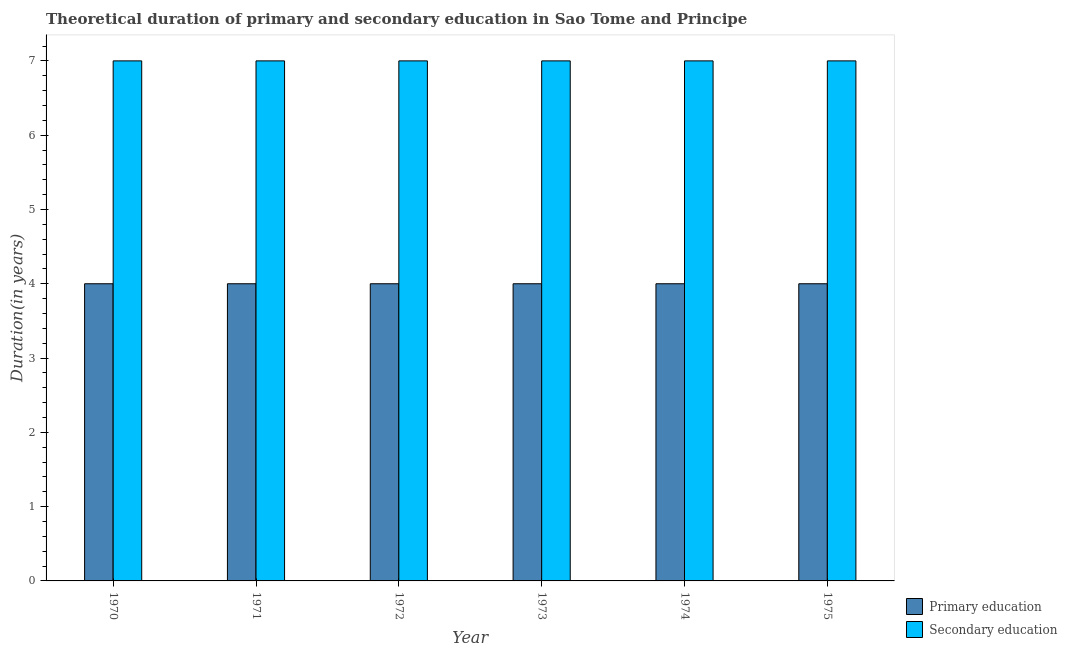How many different coloured bars are there?
Your answer should be very brief. 2. How many groups of bars are there?
Provide a short and direct response. 6. Are the number of bars per tick equal to the number of legend labels?
Your response must be concise. Yes. Are the number of bars on each tick of the X-axis equal?
Offer a very short reply. Yes. How many bars are there on the 2nd tick from the left?
Keep it short and to the point. 2. What is the label of the 4th group of bars from the left?
Provide a short and direct response. 1973. What is the duration of secondary education in 1975?
Ensure brevity in your answer.  7. Across all years, what is the maximum duration of secondary education?
Offer a very short reply. 7. Across all years, what is the minimum duration of secondary education?
Your answer should be very brief. 7. In which year was the duration of secondary education maximum?
Keep it short and to the point. 1970. What is the total duration of primary education in the graph?
Keep it short and to the point. 24. What is the difference between the duration of primary education in 1970 and that in 1971?
Offer a very short reply. 0. In how many years, is the duration of primary education greater than 2.4 years?
Your answer should be compact. 6. What is the difference between the highest and the second highest duration of secondary education?
Keep it short and to the point. 0. In how many years, is the duration of secondary education greater than the average duration of secondary education taken over all years?
Offer a very short reply. 0. Is the sum of the duration of secondary education in 1970 and 1971 greater than the maximum duration of primary education across all years?
Make the answer very short. Yes. How many bars are there?
Your answer should be very brief. 12. Are all the bars in the graph horizontal?
Keep it short and to the point. No. How many years are there in the graph?
Provide a succinct answer. 6. What is the difference between two consecutive major ticks on the Y-axis?
Your response must be concise. 1. Are the values on the major ticks of Y-axis written in scientific E-notation?
Keep it short and to the point. No. Does the graph contain grids?
Offer a terse response. No. How many legend labels are there?
Your answer should be compact. 2. How are the legend labels stacked?
Your response must be concise. Vertical. What is the title of the graph?
Ensure brevity in your answer.  Theoretical duration of primary and secondary education in Sao Tome and Principe. What is the label or title of the Y-axis?
Keep it short and to the point. Duration(in years). What is the Duration(in years) in Primary education in 1970?
Keep it short and to the point. 4. What is the Duration(in years) of Secondary education in 1972?
Your answer should be very brief. 7. What is the Duration(in years) of Secondary education in 1973?
Make the answer very short. 7. What is the Duration(in years) in Primary education in 1974?
Provide a succinct answer. 4. What is the Duration(in years) in Secondary education in 1974?
Offer a terse response. 7. What is the Duration(in years) in Primary education in 1975?
Provide a succinct answer. 4. Across all years, what is the maximum Duration(in years) of Secondary education?
Make the answer very short. 7. Across all years, what is the minimum Duration(in years) in Secondary education?
Keep it short and to the point. 7. What is the total Duration(in years) of Primary education in the graph?
Provide a succinct answer. 24. What is the difference between the Duration(in years) in Primary education in 1970 and that in 1971?
Your answer should be very brief. 0. What is the difference between the Duration(in years) in Secondary education in 1970 and that in 1971?
Your answer should be very brief. 0. What is the difference between the Duration(in years) of Primary education in 1970 and that in 1972?
Offer a terse response. 0. What is the difference between the Duration(in years) of Secondary education in 1970 and that in 1972?
Offer a terse response. 0. What is the difference between the Duration(in years) of Primary education in 1970 and that in 1973?
Provide a short and direct response. 0. What is the difference between the Duration(in years) of Secondary education in 1970 and that in 1974?
Your answer should be compact. 0. What is the difference between the Duration(in years) in Secondary education in 1970 and that in 1975?
Offer a terse response. 0. What is the difference between the Duration(in years) in Primary education in 1971 and that in 1972?
Provide a short and direct response. 0. What is the difference between the Duration(in years) in Secondary education in 1971 and that in 1973?
Offer a terse response. 0. What is the difference between the Duration(in years) in Primary education in 1971 and that in 1974?
Your answer should be compact. 0. What is the difference between the Duration(in years) of Secondary education in 1971 and that in 1975?
Offer a terse response. 0. What is the difference between the Duration(in years) in Primary education in 1972 and that in 1973?
Provide a succinct answer. 0. What is the difference between the Duration(in years) of Secondary education in 1972 and that in 1973?
Your answer should be very brief. 0. What is the difference between the Duration(in years) of Primary education in 1972 and that in 1974?
Offer a terse response. 0. What is the difference between the Duration(in years) of Secondary education in 1972 and that in 1974?
Your answer should be compact. 0. What is the difference between the Duration(in years) of Primary education in 1972 and that in 1975?
Provide a short and direct response. 0. What is the difference between the Duration(in years) in Primary education in 1973 and that in 1974?
Provide a succinct answer. 0. What is the difference between the Duration(in years) of Primary education in 1973 and that in 1975?
Offer a very short reply. 0. What is the difference between the Duration(in years) of Primary education in 1974 and that in 1975?
Offer a very short reply. 0. What is the difference between the Duration(in years) in Primary education in 1970 and the Duration(in years) in Secondary education in 1971?
Provide a short and direct response. -3. What is the difference between the Duration(in years) of Primary education in 1970 and the Duration(in years) of Secondary education in 1972?
Offer a terse response. -3. What is the difference between the Duration(in years) of Primary education in 1971 and the Duration(in years) of Secondary education in 1972?
Give a very brief answer. -3. What is the difference between the Duration(in years) of Primary education in 1971 and the Duration(in years) of Secondary education in 1973?
Your answer should be compact. -3. What is the difference between the Duration(in years) in Primary education in 1972 and the Duration(in years) in Secondary education in 1974?
Make the answer very short. -3. What is the difference between the Duration(in years) in Primary education in 1972 and the Duration(in years) in Secondary education in 1975?
Offer a very short reply. -3. What is the difference between the Duration(in years) of Primary education in 1973 and the Duration(in years) of Secondary education in 1974?
Provide a succinct answer. -3. What is the difference between the Duration(in years) in Primary education in 1973 and the Duration(in years) in Secondary education in 1975?
Keep it short and to the point. -3. What is the difference between the Duration(in years) of Primary education in 1974 and the Duration(in years) of Secondary education in 1975?
Your answer should be compact. -3. What is the average Duration(in years) in Primary education per year?
Provide a short and direct response. 4. What is the average Duration(in years) in Secondary education per year?
Make the answer very short. 7. In the year 1971, what is the difference between the Duration(in years) in Primary education and Duration(in years) in Secondary education?
Provide a succinct answer. -3. In the year 1975, what is the difference between the Duration(in years) of Primary education and Duration(in years) of Secondary education?
Offer a very short reply. -3. What is the ratio of the Duration(in years) of Secondary education in 1970 to that in 1971?
Ensure brevity in your answer.  1. What is the ratio of the Duration(in years) of Secondary education in 1970 to that in 1972?
Your answer should be very brief. 1. What is the ratio of the Duration(in years) of Primary education in 1970 to that in 1974?
Your answer should be compact. 1. What is the ratio of the Duration(in years) in Secondary education in 1970 to that in 1974?
Your answer should be compact. 1. What is the ratio of the Duration(in years) of Secondary education in 1970 to that in 1975?
Provide a succinct answer. 1. What is the ratio of the Duration(in years) in Primary education in 1971 to that in 1972?
Keep it short and to the point. 1. What is the ratio of the Duration(in years) of Primary education in 1971 to that in 1973?
Make the answer very short. 1. What is the ratio of the Duration(in years) in Secondary education in 1971 to that in 1973?
Keep it short and to the point. 1. What is the ratio of the Duration(in years) in Primary education in 1971 to that in 1974?
Your answer should be compact. 1. What is the ratio of the Duration(in years) in Primary education in 1972 to that in 1973?
Make the answer very short. 1. What is the ratio of the Duration(in years) of Primary education in 1972 to that in 1974?
Ensure brevity in your answer.  1. What is the ratio of the Duration(in years) in Secondary education in 1972 to that in 1974?
Ensure brevity in your answer.  1. What is the ratio of the Duration(in years) in Primary education in 1973 to that in 1974?
Your answer should be very brief. 1. What is the ratio of the Duration(in years) of Primary education in 1973 to that in 1975?
Your answer should be very brief. 1. What is the ratio of the Duration(in years) of Secondary education in 1973 to that in 1975?
Your answer should be compact. 1. What is the ratio of the Duration(in years) in Primary education in 1974 to that in 1975?
Give a very brief answer. 1. What is the ratio of the Duration(in years) of Secondary education in 1974 to that in 1975?
Keep it short and to the point. 1. What is the difference between the highest and the second highest Duration(in years) of Secondary education?
Your answer should be very brief. 0. What is the difference between the highest and the lowest Duration(in years) in Primary education?
Provide a short and direct response. 0. What is the difference between the highest and the lowest Duration(in years) in Secondary education?
Offer a terse response. 0. 